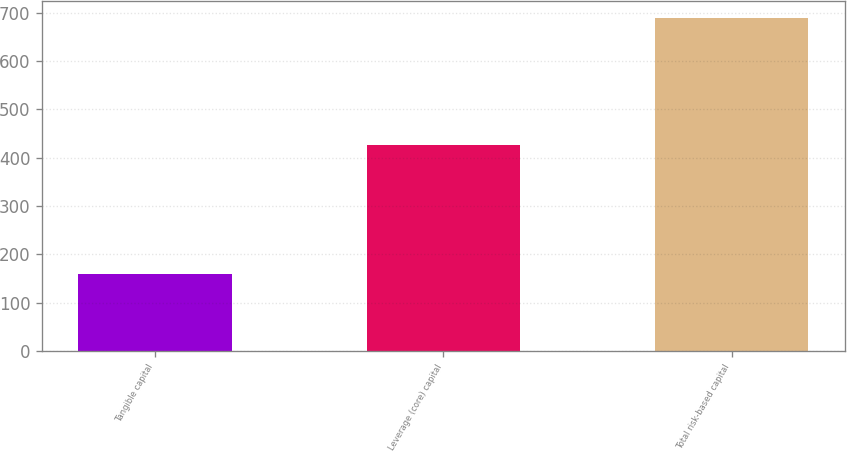<chart> <loc_0><loc_0><loc_500><loc_500><bar_chart><fcel>Tangible capital<fcel>Leverage (core) capital<fcel>Total risk-based capital<nl><fcel>159.8<fcel>426.2<fcel>689.5<nl></chart> 